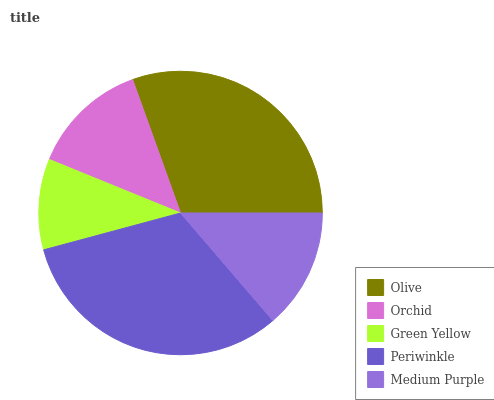Is Green Yellow the minimum?
Answer yes or no. Yes. Is Periwinkle the maximum?
Answer yes or no. Yes. Is Orchid the minimum?
Answer yes or no. No. Is Orchid the maximum?
Answer yes or no. No. Is Olive greater than Orchid?
Answer yes or no. Yes. Is Orchid less than Olive?
Answer yes or no. Yes. Is Orchid greater than Olive?
Answer yes or no. No. Is Olive less than Orchid?
Answer yes or no. No. Is Medium Purple the high median?
Answer yes or no. Yes. Is Medium Purple the low median?
Answer yes or no. Yes. Is Olive the high median?
Answer yes or no. No. Is Green Yellow the low median?
Answer yes or no. No. 